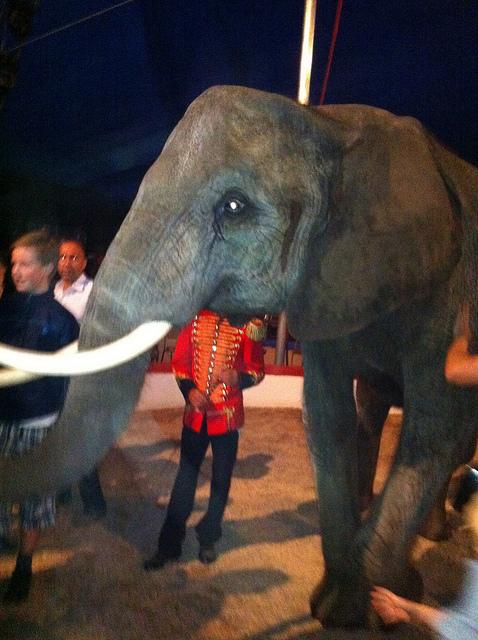What event might this be? Please explain your reasoning. circus show. There are show elephants 